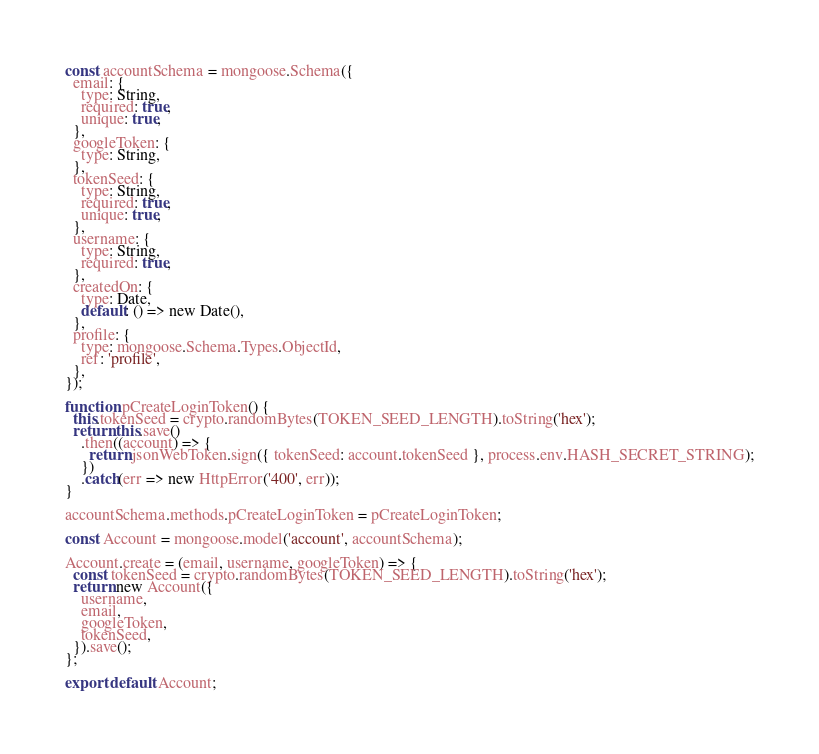Convert code to text. <code><loc_0><loc_0><loc_500><loc_500><_JavaScript_>const accountSchema = mongoose.Schema({
  email: {
    type: String,
    required: true,
    unique: true,
  },
  googleToken: {
    type: String,
  },
  tokenSeed: {
    type: String,
    required: true,
    unique: true,
  },
  username: {
    type: String,
    required: true,
  },
  createdOn: {
    type: Date,
    default: () => new Date(),
  },
  profile: {
    type: mongoose.Schema.Types.ObjectId,
    ref: 'profile',
  },
});

function pCreateLoginToken() {
  this.tokenSeed = crypto.randomBytes(TOKEN_SEED_LENGTH).toString('hex');
  return this.save()
    .then((account) => {
      return jsonWebToken.sign({ tokenSeed: account.tokenSeed }, process.env.HASH_SECRET_STRING);
    })
    .catch(err => new HttpError('400', err));
}

accountSchema.methods.pCreateLoginToken = pCreateLoginToken;

const Account = mongoose.model('account', accountSchema);

Account.create = (email, username, googleToken) => {
  const tokenSeed = crypto.randomBytes(TOKEN_SEED_LENGTH).toString('hex');
  return new Account({
    username,
    email,
    googleToken,
    tokenSeed,
  }).save();
};

export default Account;
</code> 